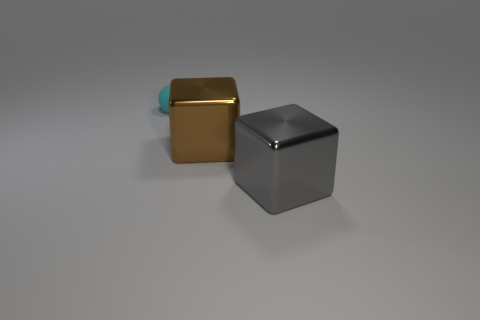Add 2 large metal objects. How many objects exist? 5 Subtract all balls. How many objects are left? 2 Subtract all green spheres. Subtract all large gray metallic objects. How many objects are left? 2 Add 2 small cyan objects. How many small cyan objects are left? 3 Add 3 large gray metal cubes. How many large gray metal cubes exist? 4 Subtract 0 green cylinders. How many objects are left? 3 